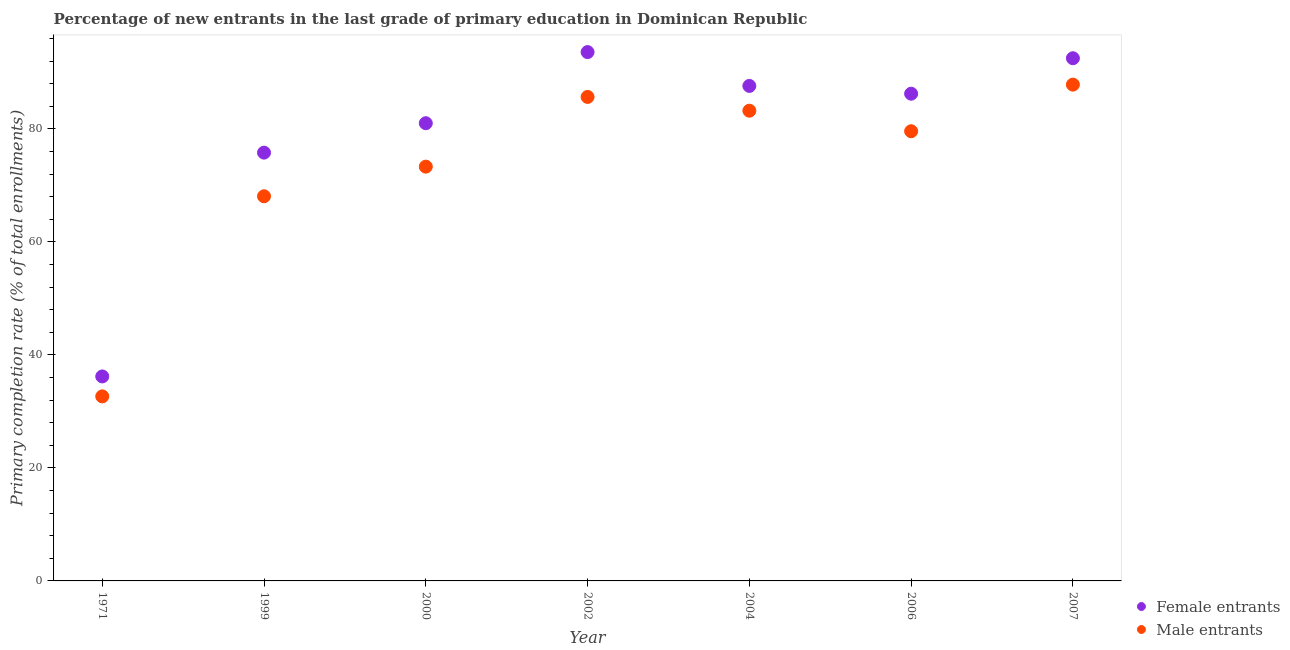What is the primary completion rate of female entrants in 2004?
Ensure brevity in your answer.  87.61. Across all years, what is the maximum primary completion rate of male entrants?
Keep it short and to the point. 87.84. Across all years, what is the minimum primary completion rate of female entrants?
Your answer should be very brief. 36.19. What is the total primary completion rate of male entrants in the graph?
Make the answer very short. 510.36. What is the difference between the primary completion rate of female entrants in 2002 and that in 2006?
Ensure brevity in your answer.  7.36. What is the difference between the primary completion rate of male entrants in 1971 and the primary completion rate of female entrants in 2000?
Provide a short and direct response. -48.35. What is the average primary completion rate of female entrants per year?
Provide a succinct answer. 78.99. In the year 1999, what is the difference between the primary completion rate of male entrants and primary completion rate of female entrants?
Provide a short and direct response. -7.73. In how many years, is the primary completion rate of male entrants greater than 4 %?
Ensure brevity in your answer.  7. What is the ratio of the primary completion rate of female entrants in 1971 to that in 2007?
Your answer should be compact. 0.39. Is the difference between the primary completion rate of female entrants in 2002 and 2006 greater than the difference between the primary completion rate of male entrants in 2002 and 2006?
Give a very brief answer. Yes. What is the difference between the highest and the second highest primary completion rate of female entrants?
Ensure brevity in your answer.  1.09. What is the difference between the highest and the lowest primary completion rate of male entrants?
Provide a short and direct response. 55.18. Is the primary completion rate of female entrants strictly greater than the primary completion rate of male entrants over the years?
Your answer should be very brief. Yes. What is the difference between two consecutive major ticks on the Y-axis?
Make the answer very short. 20. Does the graph contain any zero values?
Give a very brief answer. No. Does the graph contain grids?
Ensure brevity in your answer.  No. How are the legend labels stacked?
Keep it short and to the point. Vertical. What is the title of the graph?
Your answer should be compact. Percentage of new entrants in the last grade of primary education in Dominican Republic. Does "From human activities" appear as one of the legend labels in the graph?
Offer a very short reply. No. What is the label or title of the Y-axis?
Your answer should be compact. Primary completion rate (% of total enrollments). What is the Primary completion rate (% of total enrollments) in Female entrants in 1971?
Make the answer very short. 36.19. What is the Primary completion rate (% of total enrollments) in Male entrants in 1971?
Ensure brevity in your answer.  32.66. What is the Primary completion rate (% of total enrollments) of Female entrants in 1999?
Give a very brief answer. 75.8. What is the Primary completion rate (% of total enrollments) of Male entrants in 1999?
Keep it short and to the point. 68.07. What is the Primary completion rate (% of total enrollments) of Female entrants in 2000?
Your answer should be compact. 81.01. What is the Primary completion rate (% of total enrollments) in Male entrants in 2000?
Offer a terse response. 73.32. What is the Primary completion rate (% of total enrollments) in Female entrants in 2002?
Your response must be concise. 93.6. What is the Primary completion rate (% of total enrollments) in Male entrants in 2002?
Keep it short and to the point. 85.66. What is the Primary completion rate (% of total enrollments) of Female entrants in 2004?
Your answer should be very brief. 87.61. What is the Primary completion rate (% of total enrollments) of Male entrants in 2004?
Offer a terse response. 83.22. What is the Primary completion rate (% of total enrollments) in Female entrants in 2006?
Your response must be concise. 86.23. What is the Primary completion rate (% of total enrollments) in Male entrants in 2006?
Make the answer very short. 79.59. What is the Primary completion rate (% of total enrollments) in Female entrants in 2007?
Your answer should be compact. 92.51. What is the Primary completion rate (% of total enrollments) of Male entrants in 2007?
Make the answer very short. 87.84. Across all years, what is the maximum Primary completion rate (% of total enrollments) of Female entrants?
Provide a succinct answer. 93.6. Across all years, what is the maximum Primary completion rate (% of total enrollments) in Male entrants?
Offer a very short reply. 87.84. Across all years, what is the minimum Primary completion rate (% of total enrollments) of Female entrants?
Provide a short and direct response. 36.19. Across all years, what is the minimum Primary completion rate (% of total enrollments) of Male entrants?
Offer a very short reply. 32.66. What is the total Primary completion rate (% of total enrollments) of Female entrants in the graph?
Give a very brief answer. 552.95. What is the total Primary completion rate (% of total enrollments) of Male entrants in the graph?
Your answer should be very brief. 510.36. What is the difference between the Primary completion rate (% of total enrollments) of Female entrants in 1971 and that in 1999?
Provide a short and direct response. -39.61. What is the difference between the Primary completion rate (% of total enrollments) in Male entrants in 1971 and that in 1999?
Provide a succinct answer. -35.41. What is the difference between the Primary completion rate (% of total enrollments) of Female entrants in 1971 and that in 2000?
Offer a very short reply. -44.82. What is the difference between the Primary completion rate (% of total enrollments) of Male entrants in 1971 and that in 2000?
Offer a very short reply. -40.66. What is the difference between the Primary completion rate (% of total enrollments) of Female entrants in 1971 and that in 2002?
Offer a very short reply. -57.41. What is the difference between the Primary completion rate (% of total enrollments) of Male entrants in 1971 and that in 2002?
Your response must be concise. -53. What is the difference between the Primary completion rate (% of total enrollments) in Female entrants in 1971 and that in 2004?
Your answer should be compact. -51.42. What is the difference between the Primary completion rate (% of total enrollments) in Male entrants in 1971 and that in 2004?
Ensure brevity in your answer.  -50.56. What is the difference between the Primary completion rate (% of total enrollments) of Female entrants in 1971 and that in 2006?
Make the answer very short. -50.04. What is the difference between the Primary completion rate (% of total enrollments) in Male entrants in 1971 and that in 2006?
Ensure brevity in your answer.  -46.92. What is the difference between the Primary completion rate (% of total enrollments) in Female entrants in 1971 and that in 2007?
Offer a very short reply. -56.32. What is the difference between the Primary completion rate (% of total enrollments) in Male entrants in 1971 and that in 2007?
Give a very brief answer. -55.18. What is the difference between the Primary completion rate (% of total enrollments) in Female entrants in 1999 and that in 2000?
Ensure brevity in your answer.  -5.21. What is the difference between the Primary completion rate (% of total enrollments) of Male entrants in 1999 and that in 2000?
Keep it short and to the point. -5.25. What is the difference between the Primary completion rate (% of total enrollments) of Female entrants in 1999 and that in 2002?
Provide a succinct answer. -17.79. What is the difference between the Primary completion rate (% of total enrollments) in Male entrants in 1999 and that in 2002?
Your answer should be compact. -17.58. What is the difference between the Primary completion rate (% of total enrollments) in Female entrants in 1999 and that in 2004?
Your answer should be compact. -11.81. What is the difference between the Primary completion rate (% of total enrollments) in Male entrants in 1999 and that in 2004?
Your response must be concise. -15.15. What is the difference between the Primary completion rate (% of total enrollments) of Female entrants in 1999 and that in 2006?
Provide a short and direct response. -10.43. What is the difference between the Primary completion rate (% of total enrollments) in Male entrants in 1999 and that in 2006?
Provide a succinct answer. -11.51. What is the difference between the Primary completion rate (% of total enrollments) of Female entrants in 1999 and that in 2007?
Provide a short and direct response. -16.71. What is the difference between the Primary completion rate (% of total enrollments) of Male entrants in 1999 and that in 2007?
Make the answer very short. -19.77. What is the difference between the Primary completion rate (% of total enrollments) in Female entrants in 2000 and that in 2002?
Keep it short and to the point. -12.59. What is the difference between the Primary completion rate (% of total enrollments) in Male entrants in 2000 and that in 2002?
Give a very brief answer. -12.34. What is the difference between the Primary completion rate (% of total enrollments) of Female entrants in 2000 and that in 2004?
Provide a short and direct response. -6.6. What is the difference between the Primary completion rate (% of total enrollments) of Male entrants in 2000 and that in 2004?
Your answer should be very brief. -9.9. What is the difference between the Primary completion rate (% of total enrollments) of Female entrants in 2000 and that in 2006?
Your answer should be very brief. -5.22. What is the difference between the Primary completion rate (% of total enrollments) of Male entrants in 2000 and that in 2006?
Ensure brevity in your answer.  -6.27. What is the difference between the Primary completion rate (% of total enrollments) of Female entrants in 2000 and that in 2007?
Your answer should be very brief. -11.5. What is the difference between the Primary completion rate (% of total enrollments) in Male entrants in 2000 and that in 2007?
Ensure brevity in your answer.  -14.52. What is the difference between the Primary completion rate (% of total enrollments) of Female entrants in 2002 and that in 2004?
Your answer should be compact. 5.99. What is the difference between the Primary completion rate (% of total enrollments) of Male entrants in 2002 and that in 2004?
Keep it short and to the point. 2.44. What is the difference between the Primary completion rate (% of total enrollments) of Female entrants in 2002 and that in 2006?
Your answer should be very brief. 7.36. What is the difference between the Primary completion rate (% of total enrollments) of Male entrants in 2002 and that in 2006?
Your answer should be very brief. 6.07. What is the difference between the Primary completion rate (% of total enrollments) in Female entrants in 2002 and that in 2007?
Keep it short and to the point. 1.09. What is the difference between the Primary completion rate (% of total enrollments) of Male entrants in 2002 and that in 2007?
Give a very brief answer. -2.18. What is the difference between the Primary completion rate (% of total enrollments) of Female entrants in 2004 and that in 2006?
Give a very brief answer. 1.38. What is the difference between the Primary completion rate (% of total enrollments) in Male entrants in 2004 and that in 2006?
Your answer should be compact. 3.63. What is the difference between the Primary completion rate (% of total enrollments) in Female entrants in 2004 and that in 2007?
Keep it short and to the point. -4.9. What is the difference between the Primary completion rate (% of total enrollments) of Male entrants in 2004 and that in 2007?
Your answer should be compact. -4.62. What is the difference between the Primary completion rate (% of total enrollments) in Female entrants in 2006 and that in 2007?
Your answer should be compact. -6.28. What is the difference between the Primary completion rate (% of total enrollments) of Male entrants in 2006 and that in 2007?
Give a very brief answer. -8.25. What is the difference between the Primary completion rate (% of total enrollments) in Female entrants in 1971 and the Primary completion rate (% of total enrollments) in Male entrants in 1999?
Your answer should be very brief. -31.88. What is the difference between the Primary completion rate (% of total enrollments) in Female entrants in 1971 and the Primary completion rate (% of total enrollments) in Male entrants in 2000?
Keep it short and to the point. -37.13. What is the difference between the Primary completion rate (% of total enrollments) in Female entrants in 1971 and the Primary completion rate (% of total enrollments) in Male entrants in 2002?
Provide a succinct answer. -49.47. What is the difference between the Primary completion rate (% of total enrollments) in Female entrants in 1971 and the Primary completion rate (% of total enrollments) in Male entrants in 2004?
Your answer should be very brief. -47.03. What is the difference between the Primary completion rate (% of total enrollments) in Female entrants in 1971 and the Primary completion rate (% of total enrollments) in Male entrants in 2006?
Make the answer very short. -43.4. What is the difference between the Primary completion rate (% of total enrollments) of Female entrants in 1971 and the Primary completion rate (% of total enrollments) of Male entrants in 2007?
Your response must be concise. -51.65. What is the difference between the Primary completion rate (% of total enrollments) in Female entrants in 1999 and the Primary completion rate (% of total enrollments) in Male entrants in 2000?
Your response must be concise. 2.48. What is the difference between the Primary completion rate (% of total enrollments) in Female entrants in 1999 and the Primary completion rate (% of total enrollments) in Male entrants in 2002?
Provide a succinct answer. -9.86. What is the difference between the Primary completion rate (% of total enrollments) of Female entrants in 1999 and the Primary completion rate (% of total enrollments) of Male entrants in 2004?
Ensure brevity in your answer.  -7.42. What is the difference between the Primary completion rate (% of total enrollments) in Female entrants in 1999 and the Primary completion rate (% of total enrollments) in Male entrants in 2006?
Your response must be concise. -3.79. What is the difference between the Primary completion rate (% of total enrollments) of Female entrants in 1999 and the Primary completion rate (% of total enrollments) of Male entrants in 2007?
Your answer should be very brief. -12.04. What is the difference between the Primary completion rate (% of total enrollments) in Female entrants in 2000 and the Primary completion rate (% of total enrollments) in Male entrants in 2002?
Offer a very short reply. -4.65. What is the difference between the Primary completion rate (% of total enrollments) of Female entrants in 2000 and the Primary completion rate (% of total enrollments) of Male entrants in 2004?
Offer a very short reply. -2.21. What is the difference between the Primary completion rate (% of total enrollments) of Female entrants in 2000 and the Primary completion rate (% of total enrollments) of Male entrants in 2006?
Provide a short and direct response. 1.42. What is the difference between the Primary completion rate (% of total enrollments) in Female entrants in 2000 and the Primary completion rate (% of total enrollments) in Male entrants in 2007?
Ensure brevity in your answer.  -6.83. What is the difference between the Primary completion rate (% of total enrollments) of Female entrants in 2002 and the Primary completion rate (% of total enrollments) of Male entrants in 2004?
Keep it short and to the point. 10.38. What is the difference between the Primary completion rate (% of total enrollments) of Female entrants in 2002 and the Primary completion rate (% of total enrollments) of Male entrants in 2006?
Give a very brief answer. 14.01. What is the difference between the Primary completion rate (% of total enrollments) in Female entrants in 2002 and the Primary completion rate (% of total enrollments) in Male entrants in 2007?
Offer a terse response. 5.76. What is the difference between the Primary completion rate (% of total enrollments) in Female entrants in 2004 and the Primary completion rate (% of total enrollments) in Male entrants in 2006?
Provide a succinct answer. 8.02. What is the difference between the Primary completion rate (% of total enrollments) of Female entrants in 2004 and the Primary completion rate (% of total enrollments) of Male entrants in 2007?
Make the answer very short. -0.23. What is the difference between the Primary completion rate (% of total enrollments) of Female entrants in 2006 and the Primary completion rate (% of total enrollments) of Male entrants in 2007?
Your answer should be compact. -1.61. What is the average Primary completion rate (% of total enrollments) in Female entrants per year?
Offer a very short reply. 78.99. What is the average Primary completion rate (% of total enrollments) in Male entrants per year?
Your answer should be compact. 72.91. In the year 1971, what is the difference between the Primary completion rate (% of total enrollments) in Female entrants and Primary completion rate (% of total enrollments) in Male entrants?
Make the answer very short. 3.53. In the year 1999, what is the difference between the Primary completion rate (% of total enrollments) in Female entrants and Primary completion rate (% of total enrollments) in Male entrants?
Keep it short and to the point. 7.73. In the year 2000, what is the difference between the Primary completion rate (% of total enrollments) of Female entrants and Primary completion rate (% of total enrollments) of Male entrants?
Your answer should be very brief. 7.69. In the year 2002, what is the difference between the Primary completion rate (% of total enrollments) in Female entrants and Primary completion rate (% of total enrollments) in Male entrants?
Keep it short and to the point. 7.94. In the year 2004, what is the difference between the Primary completion rate (% of total enrollments) of Female entrants and Primary completion rate (% of total enrollments) of Male entrants?
Your response must be concise. 4.39. In the year 2006, what is the difference between the Primary completion rate (% of total enrollments) in Female entrants and Primary completion rate (% of total enrollments) in Male entrants?
Offer a terse response. 6.64. In the year 2007, what is the difference between the Primary completion rate (% of total enrollments) in Female entrants and Primary completion rate (% of total enrollments) in Male entrants?
Offer a terse response. 4.67. What is the ratio of the Primary completion rate (% of total enrollments) in Female entrants in 1971 to that in 1999?
Ensure brevity in your answer.  0.48. What is the ratio of the Primary completion rate (% of total enrollments) in Male entrants in 1971 to that in 1999?
Your answer should be compact. 0.48. What is the ratio of the Primary completion rate (% of total enrollments) of Female entrants in 1971 to that in 2000?
Give a very brief answer. 0.45. What is the ratio of the Primary completion rate (% of total enrollments) in Male entrants in 1971 to that in 2000?
Ensure brevity in your answer.  0.45. What is the ratio of the Primary completion rate (% of total enrollments) in Female entrants in 1971 to that in 2002?
Your answer should be compact. 0.39. What is the ratio of the Primary completion rate (% of total enrollments) of Male entrants in 1971 to that in 2002?
Your answer should be very brief. 0.38. What is the ratio of the Primary completion rate (% of total enrollments) in Female entrants in 1971 to that in 2004?
Your answer should be compact. 0.41. What is the ratio of the Primary completion rate (% of total enrollments) of Male entrants in 1971 to that in 2004?
Keep it short and to the point. 0.39. What is the ratio of the Primary completion rate (% of total enrollments) in Female entrants in 1971 to that in 2006?
Ensure brevity in your answer.  0.42. What is the ratio of the Primary completion rate (% of total enrollments) of Male entrants in 1971 to that in 2006?
Offer a terse response. 0.41. What is the ratio of the Primary completion rate (% of total enrollments) in Female entrants in 1971 to that in 2007?
Provide a succinct answer. 0.39. What is the ratio of the Primary completion rate (% of total enrollments) in Male entrants in 1971 to that in 2007?
Your answer should be very brief. 0.37. What is the ratio of the Primary completion rate (% of total enrollments) in Female entrants in 1999 to that in 2000?
Make the answer very short. 0.94. What is the ratio of the Primary completion rate (% of total enrollments) in Male entrants in 1999 to that in 2000?
Keep it short and to the point. 0.93. What is the ratio of the Primary completion rate (% of total enrollments) in Female entrants in 1999 to that in 2002?
Your answer should be very brief. 0.81. What is the ratio of the Primary completion rate (% of total enrollments) in Male entrants in 1999 to that in 2002?
Provide a short and direct response. 0.79. What is the ratio of the Primary completion rate (% of total enrollments) of Female entrants in 1999 to that in 2004?
Keep it short and to the point. 0.87. What is the ratio of the Primary completion rate (% of total enrollments) in Male entrants in 1999 to that in 2004?
Your answer should be very brief. 0.82. What is the ratio of the Primary completion rate (% of total enrollments) in Female entrants in 1999 to that in 2006?
Ensure brevity in your answer.  0.88. What is the ratio of the Primary completion rate (% of total enrollments) of Male entrants in 1999 to that in 2006?
Your response must be concise. 0.86. What is the ratio of the Primary completion rate (% of total enrollments) in Female entrants in 1999 to that in 2007?
Keep it short and to the point. 0.82. What is the ratio of the Primary completion rate (% of total enrollments) of Male entrants in 1999 to that in 2007?
Your answer should be very brief. 0.78. What is the ratio of the Primary completion rate (% of total enrollments) of Female entrants in 2000 to that in 2002?
Provide a short and direct response. 0.87. What is the ratio of the Primary completion rate (% of total enrollments) in Male entrants in 2000 to that in 2002?
Your answer should be very brief. 0.86. What is the ratio of the Primary completion rate (% of total enrollments) of Female entrants in 2000 to that in 2004?
Offer a very short reply. 0.92. What is the ratio of the Primary completion rate (% of total enrollments) in Male entrants in 2000 to that in 2004?
Keep it short and to the point. 0.88. What is the ratio of the Primary completion rate (% of total enrollments) of Female entrants in 2000 to that in 2006?
Give a very brief answer. 0.94. What is the ratio of the Primary completion rate (% of total enrollments) of Male entrants in 2000 to that in 2006?
Keep it short and to the point. 0.92. What is the ratio of the Primary completion rate (% of total enrollments) of Female entrants in 2000 to that in 2007?
Give a very brief answer. 0.88. What is the ratio of the Primary completion rate (% of total enrollments) in Male entrants in 2000 to that in 2007?
Offer a very short reply. 0.83. What is the ratio of the Primary completion rate (% of total enrollments) of Female entrants in 2002 to that in 2004?
Provide a short and direct response. 1.07. What is the ratio of the Primary completion rate (% of total enrollments) in Male entrants in 2002 to that in 2004?
Provide a short and direct response. 1.03. What is the ratio of the Primary completion rate (% of total enrollments) of Female entrants in 2002 to that in 2006?
Give a very brief answer. 1.09. What is the ratio of the Primary completion rate (% of total enrollments) of Male entrants in 2002 to that in 2006?
Your response must be concise. 1.08. What is the ratio of the Primary completion rate (% of total enrollments) of Female entrants in 2002 to that in 2007?
Your answer should be very brief. 1.01. What is the ratio of the Primary completion rate (% of total enrollments) of Male entrants in 2002 to that in 2007?
Provide a succinct answer. 0.98. What is the ratio of the Primary completion rate (% of total enrollments) in Male entrants in 2004 to that in 2006?
Keep it short and to the point. 1.05. What is the ratio of the Primary completion rate (% of total enrollments) in Female entrants in 2004 to that in 2007?
Your response must be concise. 0.95. What is the ratio of the Primary completion rate (% of total enrollments) in Female entrants in 2006 to that in 2007?
Provide a short and direct response. 0.93. What is the ratio of the Primary completion rate (% of total enrollments) of Male entrants in 2006 to that in 2007?
Offer a very short reply. 0.91. What is the difference between the highest and the second highest Primary completion rate (% of total enrollments) of Female entrants?
Your answer should be compact. 1.09. What is the difference between the highest and the second highest Primary completion rate (% of total enrollments) of Male entrants?
Give a very brief answer. 2.18. What is the difference between the highest and the lowest Primary completion rate (% of total enrollments) of Female entrants?
Provide a succinct answer. 57.41. What is the difference between the highest and the lowest Primary completion rate (% of total enrollments) in Male entrants?
Your answer should be very brief. 55.18. 